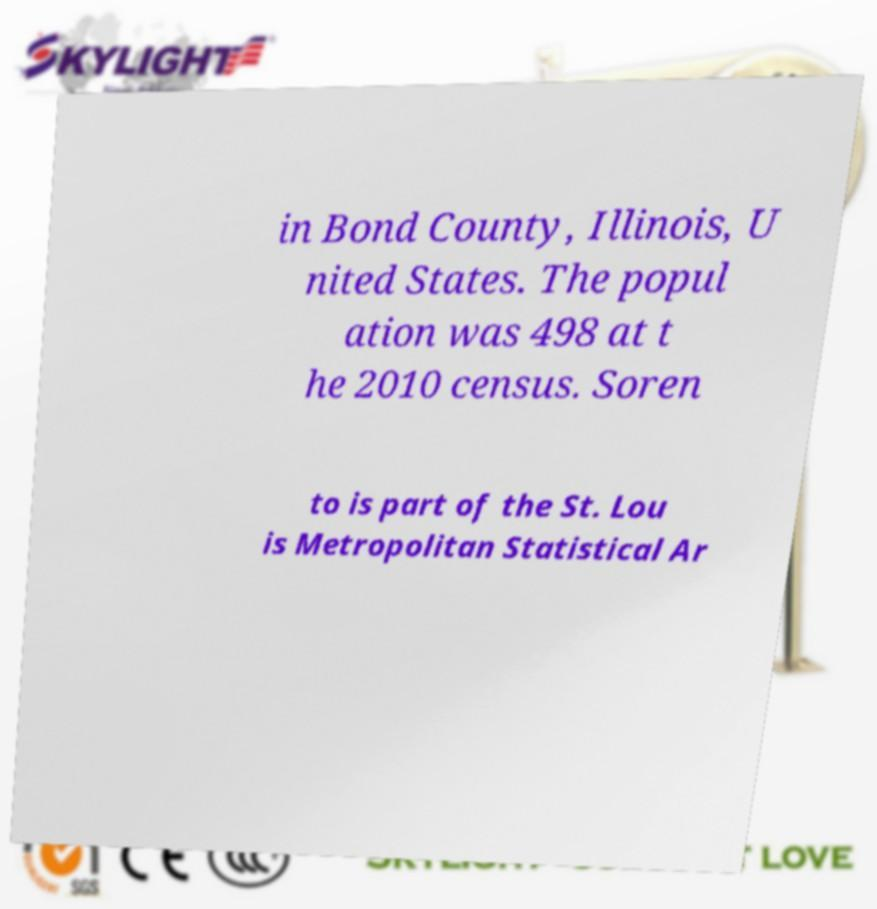Please identify and transcribe the text found in this image. in Bond County, Illinois, U nited States. The popul ation was 498 at t he 2010 census. Soren to is part of the St. Lou is Metropolitan Statistical Ar 